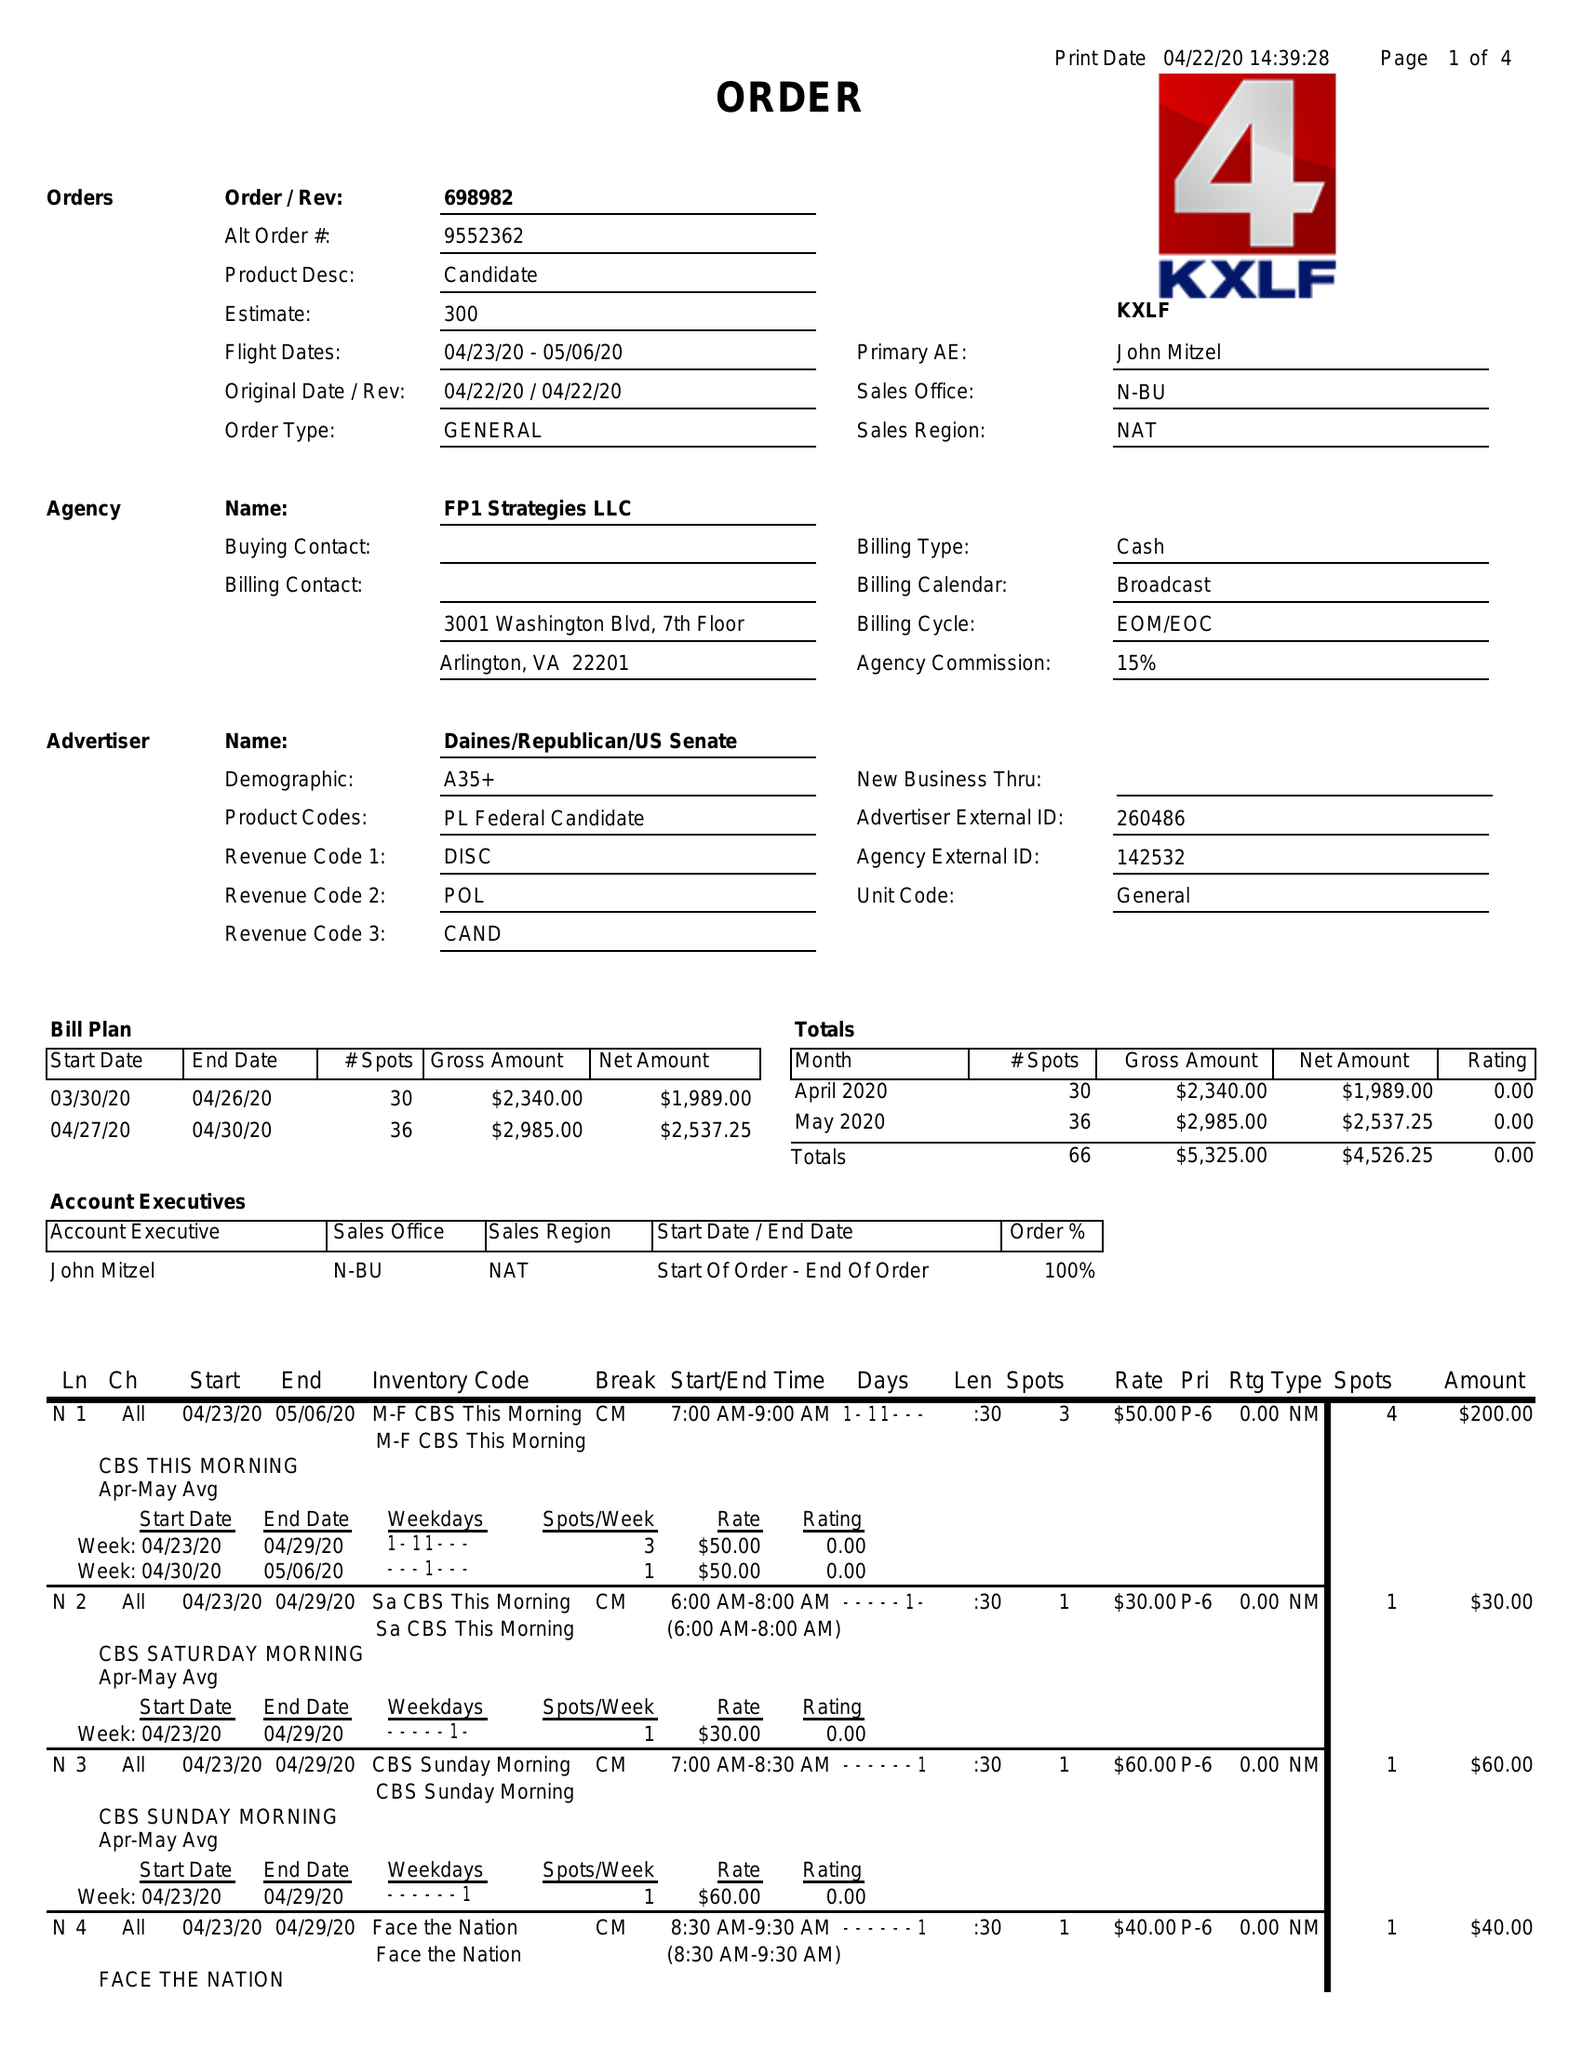What is the value for the flight_from?
Answer the question using a single word or phrase. 04/23/20 